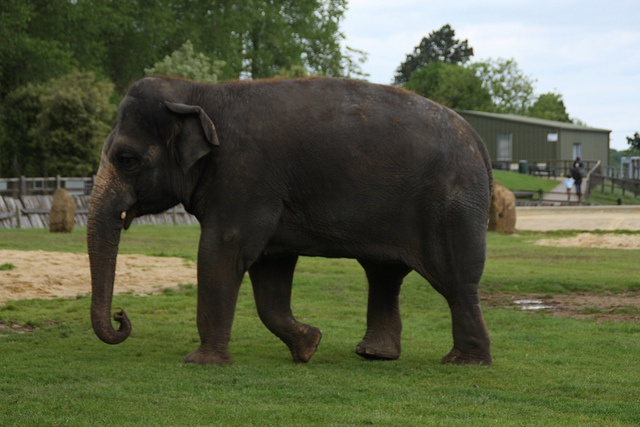Describe the objects in this image and their specific colors. I can see elephant in black, gray, and darkgreen tones, people in black, gray, and navy tones, and people in black, darkgray, lightblue, and gray tones in this image. 